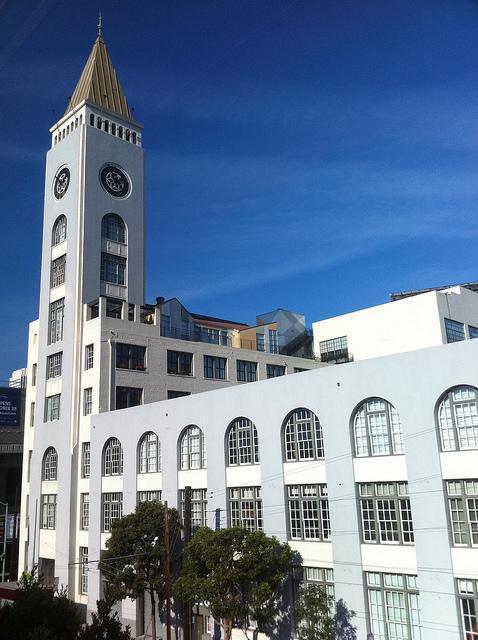How many people are playing?
Give a very brief answer. 0. 